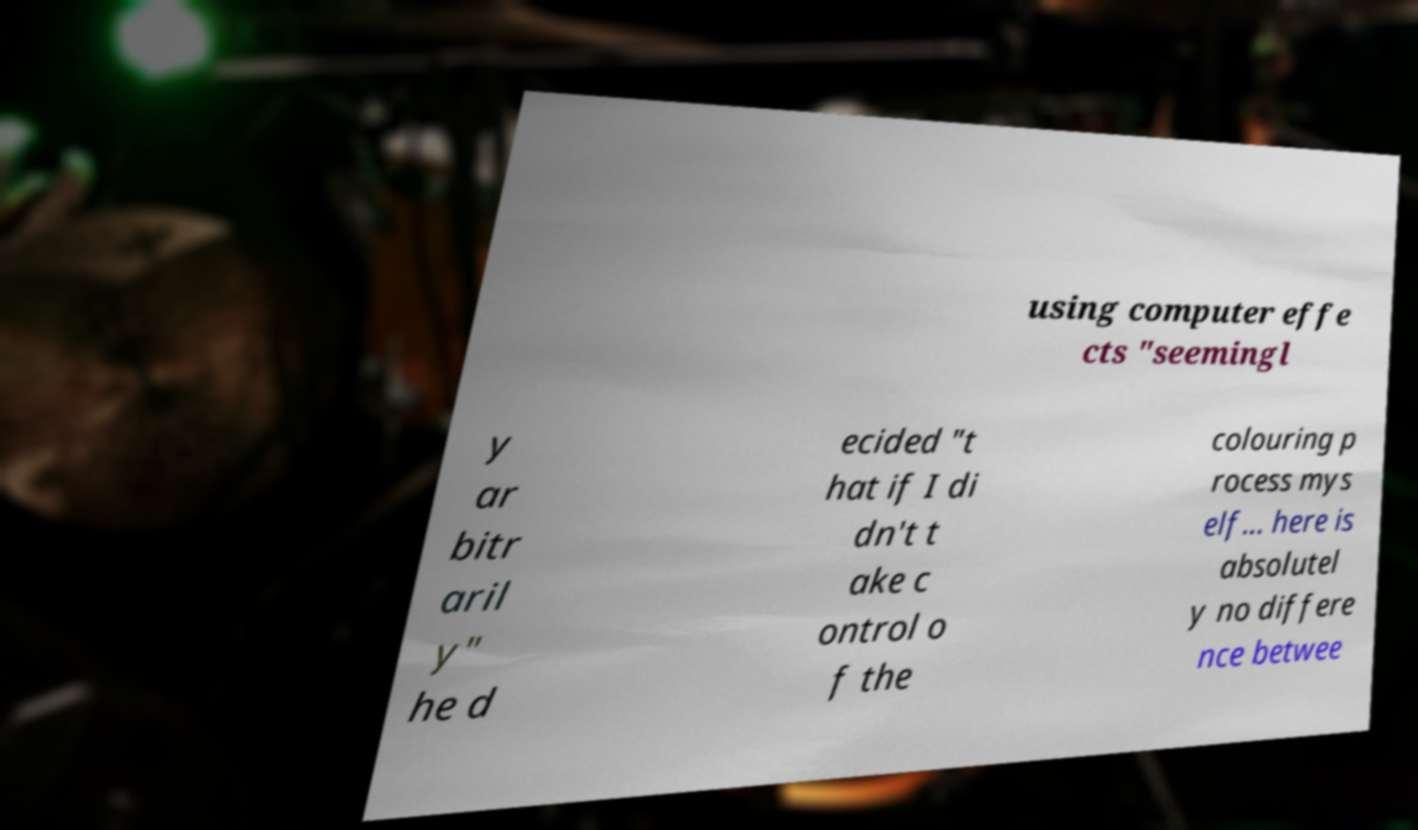Please identify and transcribe the text found in this image. using computer effe cts "seemingl y ar bitr aril y" he d ecided "t hat if I di dn't t ake c ontrol o f the colouring p rocess mys elf... here is absolutel y no differe nce betwee 